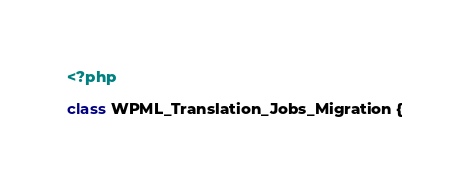<code> <loc_0><loc_0><loc_500><loc_500><_PHP_><?php

class WPML_Translation_Jobs_Migration {
</code> 